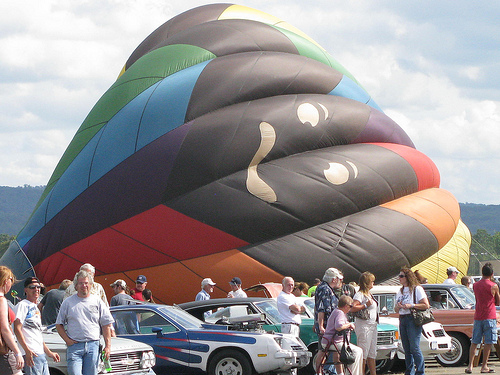<image>
Is the car in front of the balloon? Yes. The car is positioned in front of the balloon, appearing closer to the camera viewpoint. 